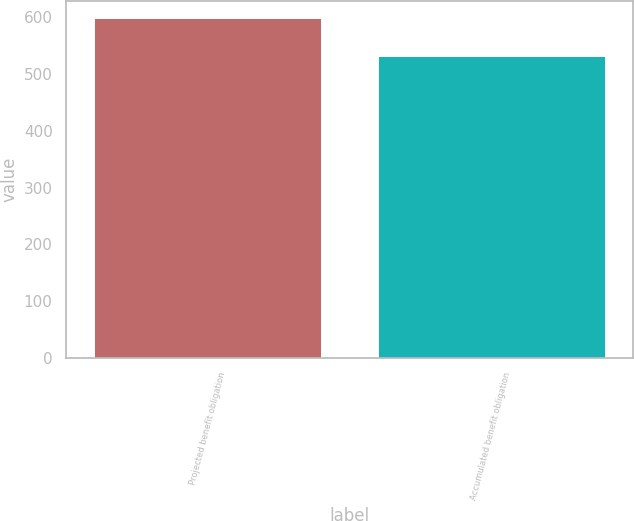Convert chart. <chart><loc_0><loc_0><loc_500><loc_500><bar_chart><fcel>Projected benefit obligation<fcel>Accumulated benefit obligation<nl><fcel>598.7<fcel>531.4<nl></chart> 